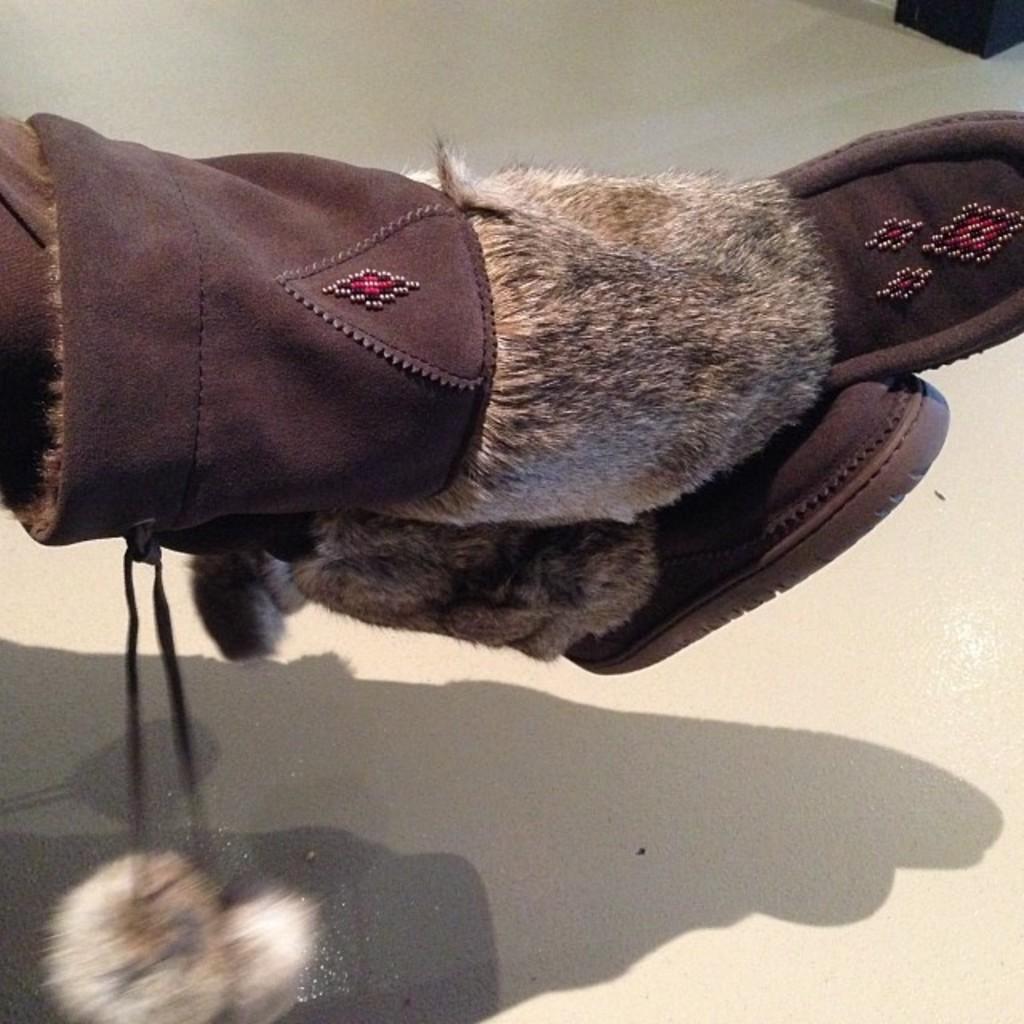Can you describe this image briefly? In this image we can see the legs of a person wearing boots. 